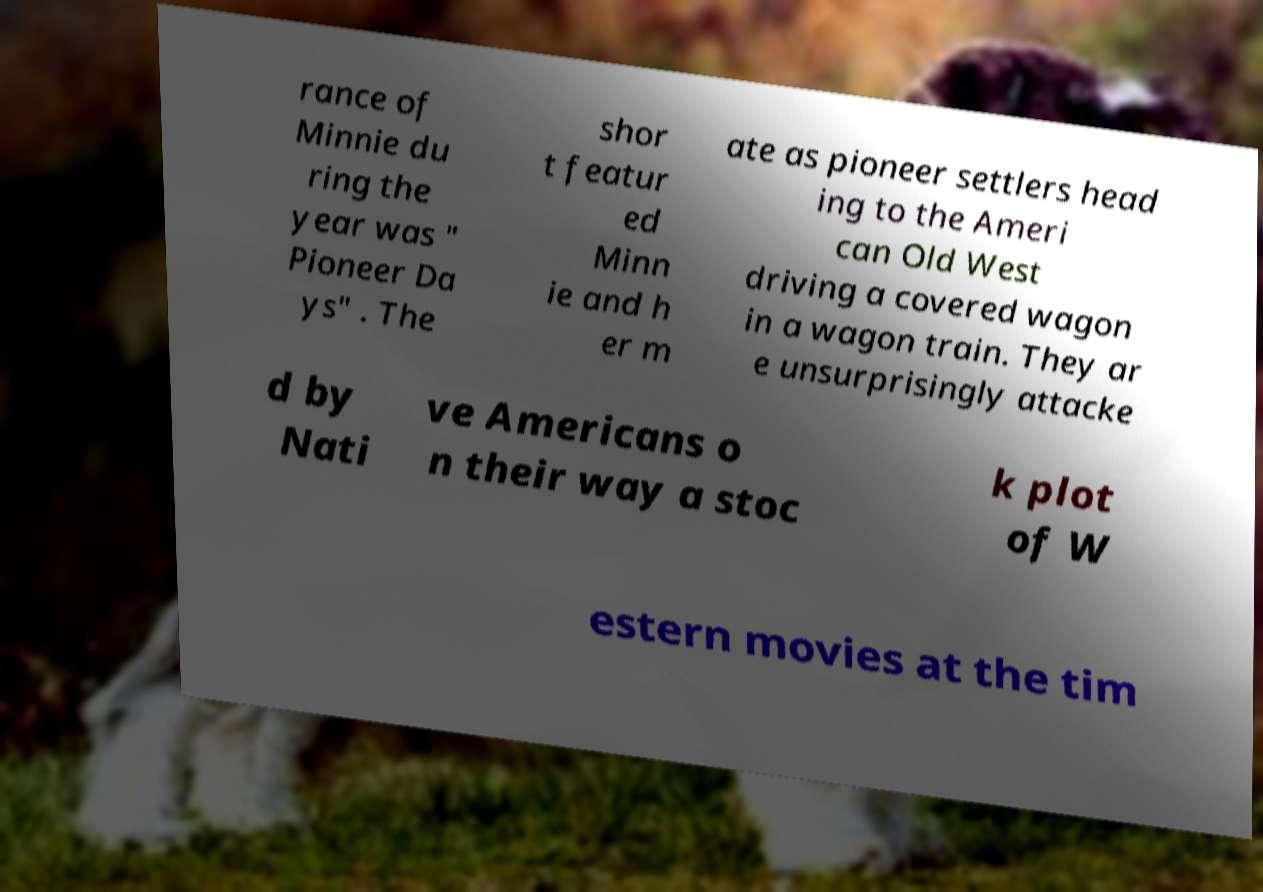Can you accurately transcribe the text from the provided image for me? rance of Minnie du ring the year was " Pioneer Da ys" . The shor t featur ed Minn ie and h er m ate as pioneer settlers head ing to the Ameri can Old West driving a covered wagon in a wagon train. They ar e unsurprisingly attacke d by Nati ve Americans o n their way a stoc k plot of W estern movies at the tim 